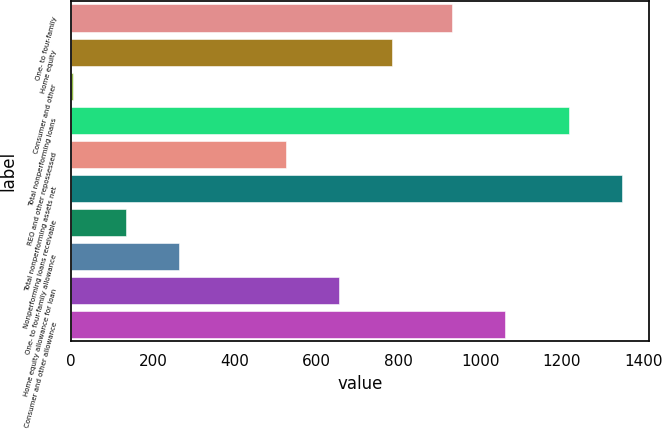Convert chart. <chart><loc_0><loc_0><loc_500><loc_500><bar_chart><fcel>One- to four-family<fcel>Home equity<fcel>Consumer and other<fcel>Total nonperforming loans<fcel>REO and other repossessed<fcel>Total nonperforming assets net<fcel>Nonperforming loans receivable<fcel>One- to four-family allowance<fcel>Home equity allowance for loan<fcel>Consumer and other allowance<nl><fcel>930.2<fcel>784.02<fcel>4.5<fcel>1216.1<fcel>524.18<fcel>1346.02<fcel>134.42<fcel>264.34<fcel>654.1<fcel>1060.12<nl></chart> 